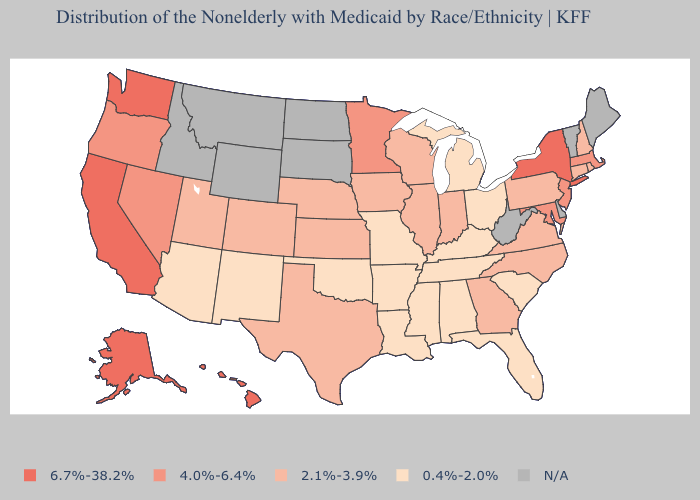What is the lowest value in states that border Missouri?
Give a very brief answer. 0.4%-2.0%. Does Colorado have the highest value in the USA?
Keep it brief. No. Is the legend a continuous bar?
Short answer required. No. Is the legend a continuous bar?
Give a very brief answer. No. What is the value of Michigan?
Keep it brief. 0.4%-2.0%. What is the highest value in the Northeast ?
Answer briefly. 6.7%-38.2%. Name the states that have a value in the range 6.7%-38.2%?
Quick response, please. Alaska, California, Hawaii, New York, Washington. What is the lowest value in states that border Utah?
Be succinct. 0.4%-2.0%. Among the states that border Tennessee , does Virginia have the highest value?
Concise answer only. Yes. Does Ohio have the highest value in the MidWest?
Keep it brief. No. Name the states that have a value in the range 4.0%-6.4%?
Keep it brief. Maryland, Massachusetts, Minnesota, Nevada, New Jersey, Oregon. Name the states that have a value in the range 6.7%-38.2%?
Quick response, please. Alaska, California, Hawaii, New York, Washington. What is the value of Nevada?
Write a very short answer. 4.0%-6.4%. Name the states that have a value in the range 6.7%-38.2%?
Write a very short answer. Alaska, California, Hawaii, New York, Washington. 